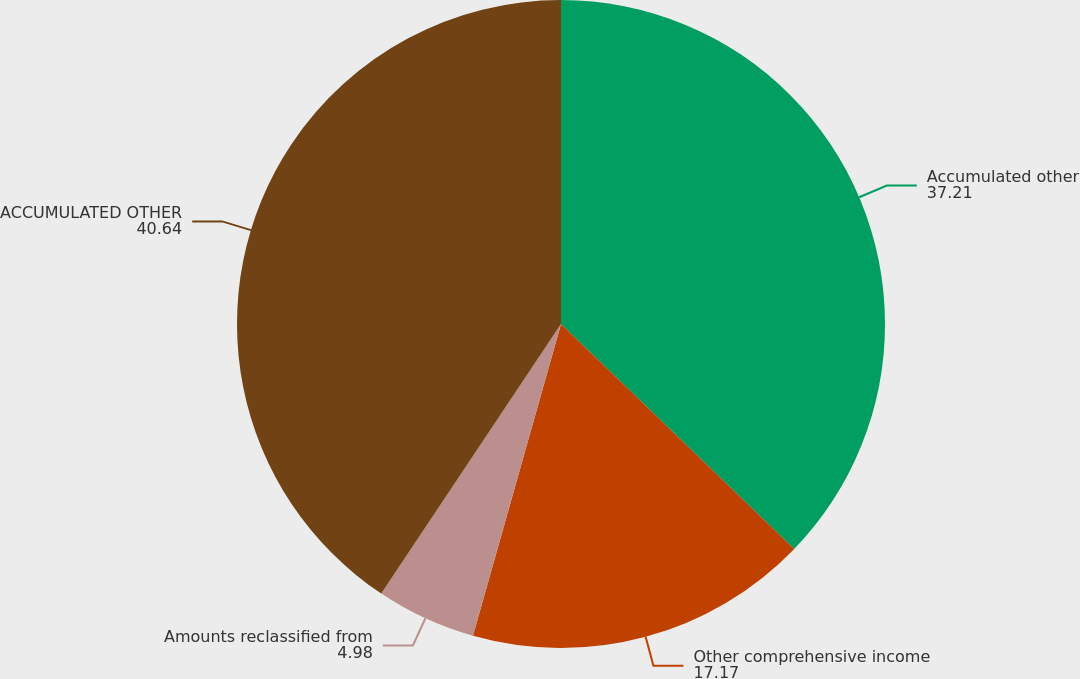Convert chart. <chart><loc_0><loc_0><loc_500><loc_500><pie_chart><fcel>Accumulated other<fcel>Other comprehensive income<fcel>Amounts reclassified from<fcel>ACCUMULATED OTHER<nl><fcel>37.21%<fcel>17.17%<fcel>4.98%<fcel>40.64%<nl></chart> 